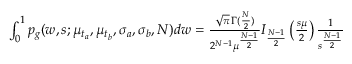<formula> <loc_0><loc_0><loc_500><loc_500>\begin{array} { r } { \int _ { 0 } ^ { 1 } p _ { g } ( w , s ; \mu _ { t _ { a } } , \mu _ { t _ { b } } , \sigma _ { a } , \sigma _ { b } , N ) d w = \frac { \sqrt { \pi } \, \Gamma ( \frac { N } { 2 } ) } { 2 ^ { N - 1 } \mu ^ { \frac { N - 1 } { 2 } } } I _ { \frac { N - 1 } { 2 } } \left ( \frac { s \mu } { 2 } \right ) \frac { 1 } { s ^ { \frac { N - 1 } { 2 } } } } \end{array}</formula> 